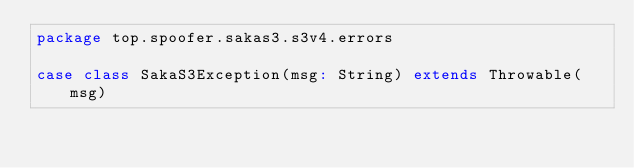Convert code to text. <code><loc_0><loc_0><loc_500><loc_500><_Scala_>package top.spoofer.sakas3.s3v4.errors

case class SakaS3Exception(msg: String) extends Throwable(msg)
</code> 